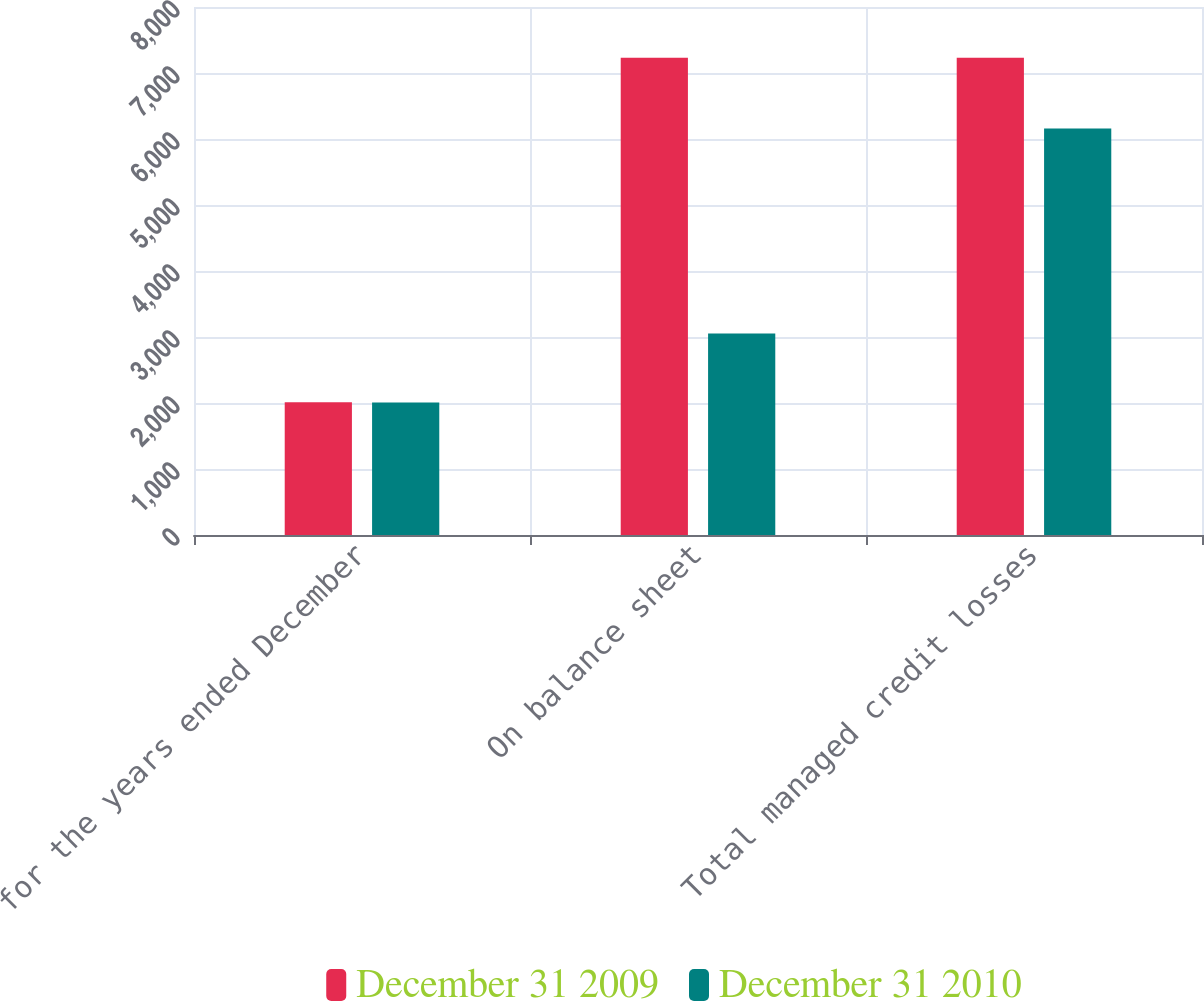<chart> <loc_0><loc_0><loc_500><loc_500><stacked_bar_chart><ecel><fcel>for the years ended December<fcel>On balance sheet<fcel>Total managed credit losses<nl><fcel>December 31 2009<fcel>2010<fcel>7230<fcel>7230<nl><fcel>December 31 2010<fcel>2008<fcel>3052<fcel>6159<nl></chart> 